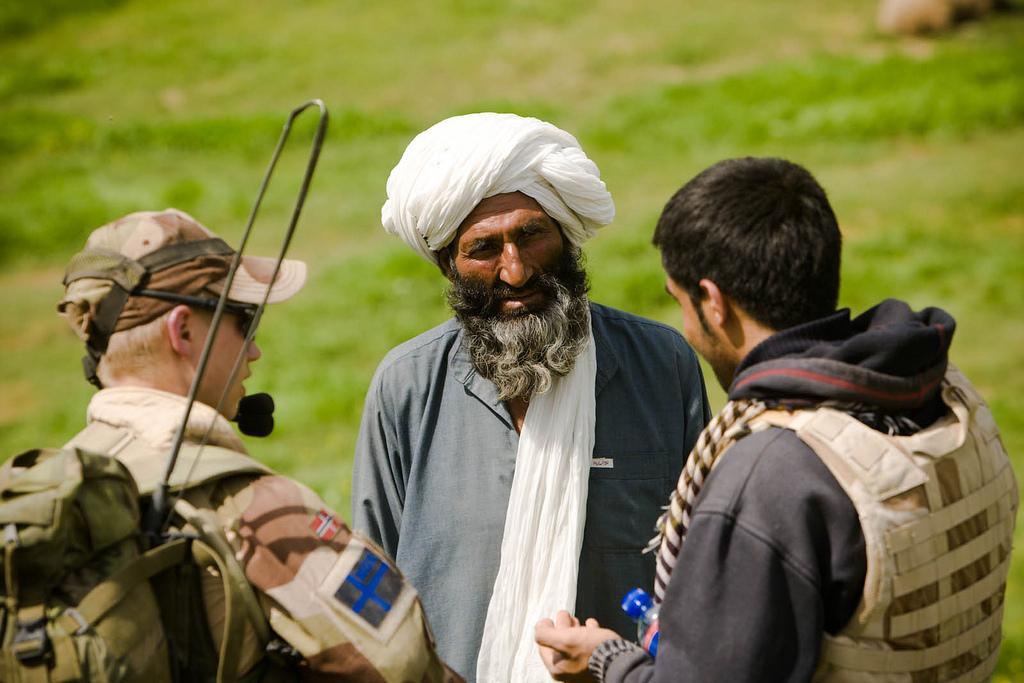How many people are in the image? There are three men in the image. What are the men wearing? The men are wearing bags. Can you describe the background of the image? The background of the image is blurred. What type of environment can be seen in the background? There is greenery visible in the background. What color is the mitten hanging on the tree in the image? There is no mitten present in the image. How does the moon affect the lighting in the image? The image does not depict the moon, so its effect on the lighting cannot be determined. 